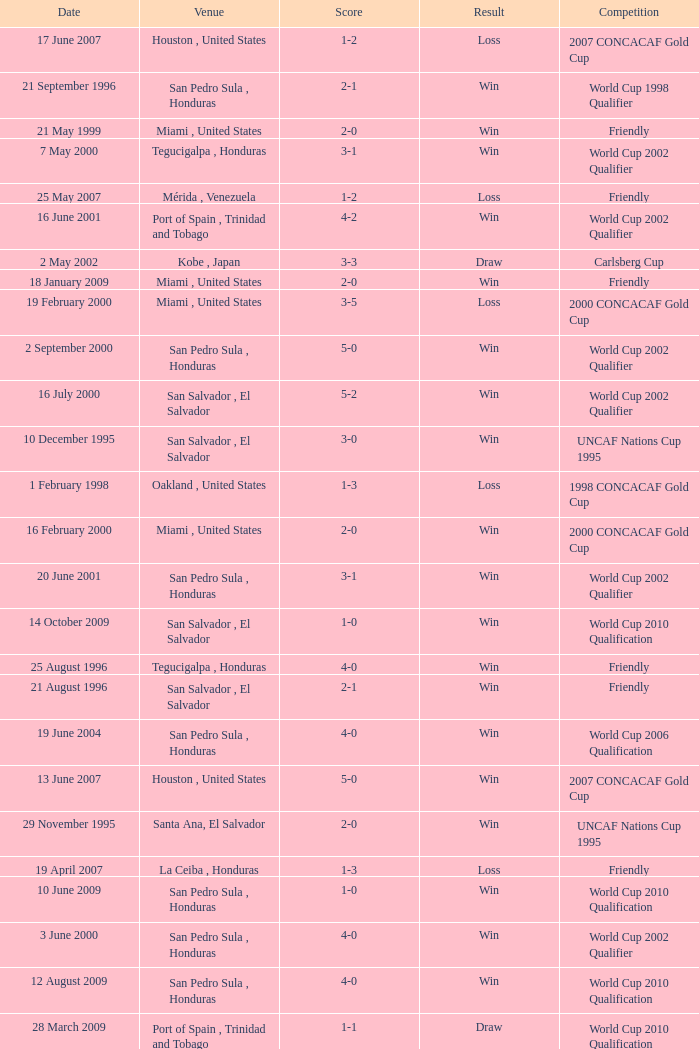Name the score for 7 may 2000 3-1. 